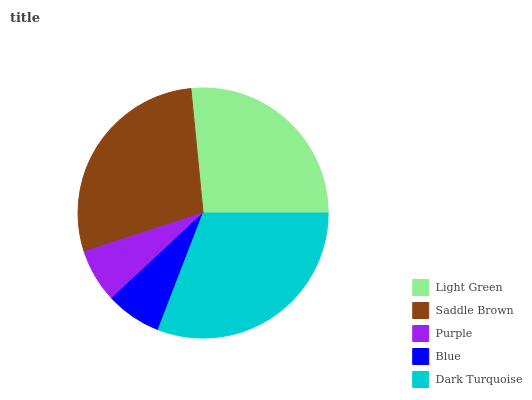Is Purple the minimum?
Answer yes or no. Yes. Is Dark Turquoise the maximum?
Answer yes or no. Yes. Is Saddle Brown the minimum?
Answer yes or no. No. Is Saddle Brown the maximum?
Answer yes or no. No. Is Saddle Brown greater than Light Green?
Answer yes or no. Yes. Is Light Green less than Saddle Brown?
Answer yes or no. Yes. Is Light Green greater than Saddle Brown?
Answer yes or no. No. Is Saddle Brown less than Light Green?
Answer yes or no. No. Is Light Green the high median?
Answer yes or no. Yes. Is Light Green the low median?
Answer yes or no. Yes. Is Dark Turquoise the high median?
Answer yes or no. No. Is Dark Turquoise the low median?
Answer yes or no. No. 